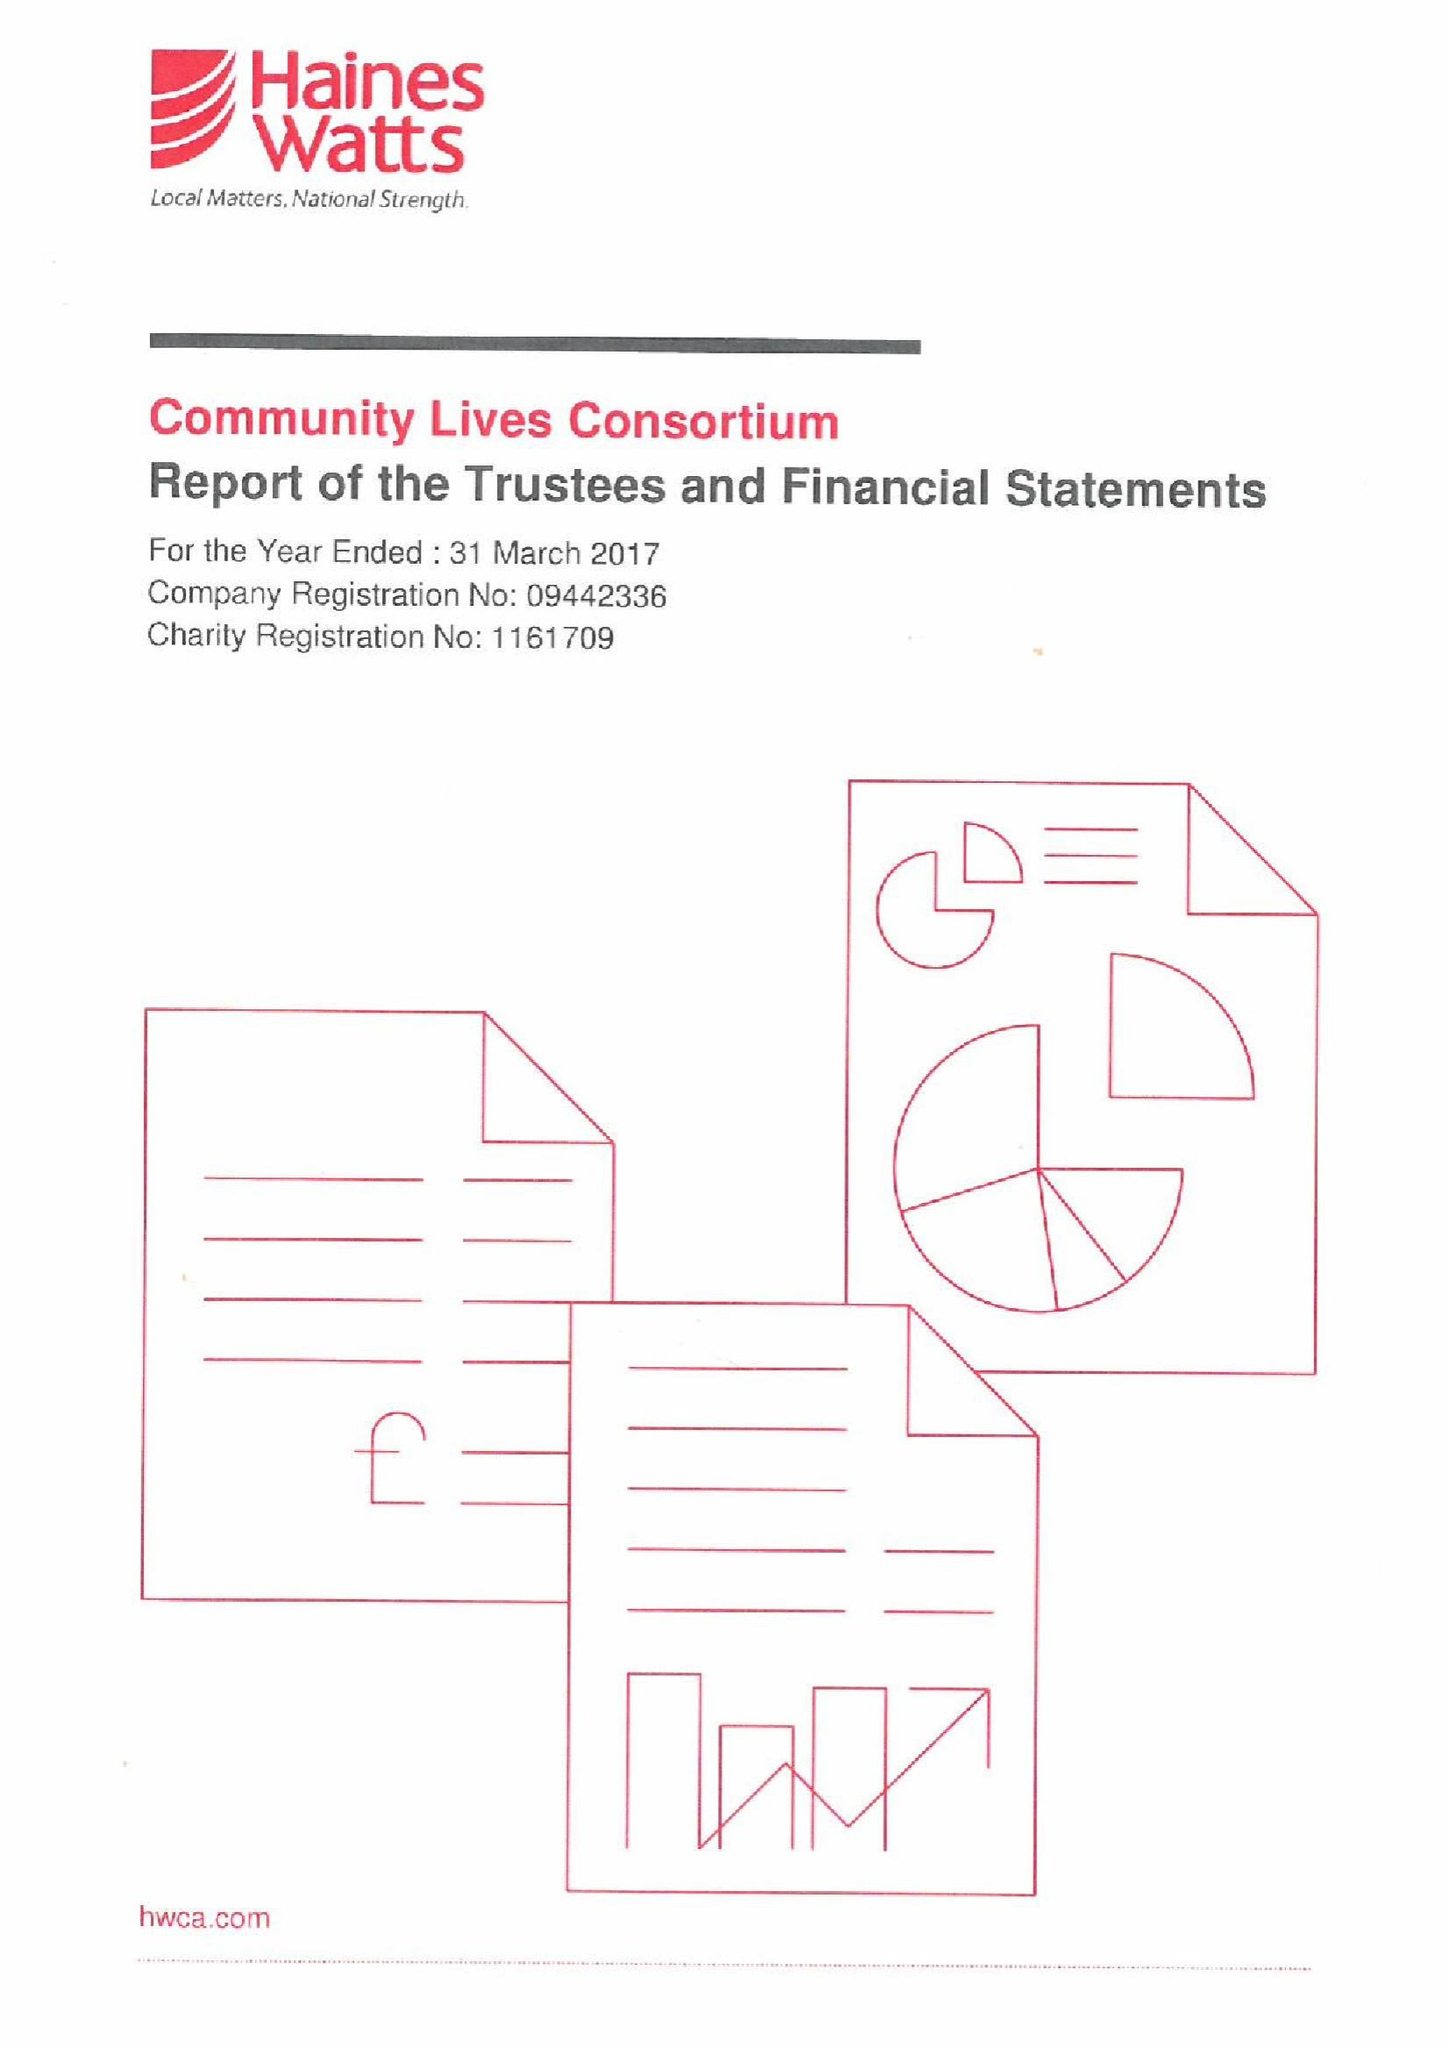What is the value for the report_date?
Answer the question using a single word or phrase. 2017-03-31 